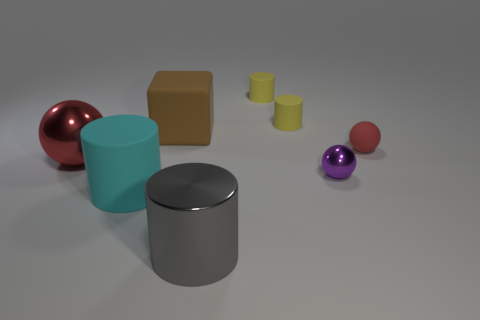What shape is the red thing that is the same material as the large gray cylinder?
Make the answer very short. Sphere. How many things are either matte cylinders that are in front of the red rubber sphere or matte cylinders that are behind the cyan cylinder?
Keep it short and to the point. 3. There is a big matte object in front of the small thing that is to the right of the small purple object; what number of small red spheres are right of it?
Your answer should be very brief. 1. There is a shiny thing right of the large gray object; what size is it?
Provide a succinct answer. Small. How many brown things have the same size as the purple ball?
Provide a short and direct response. 0. There is a metallic cylinder; is its size the same as the ball that is on the right side of the small metal sphere?
Make the answer very short. No. What number of things are cyan metal spheres or brown rubber blocks?
Keep it short and to the point. 1. What number of other spheres are the same color as the matte sphere?
Your response must be concise. 1. The gray thing that is the same size as the cyan rubber thing is what shape?
Make the answer very short. Cylinder. Are there any brown objects that have the same shape as the cyan object?
Your answer should be very brief. No. 